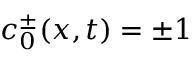Convert formula to latex. <formula><loc_0><loc_0><loc_500><loc_500>c _ { 0 } ^ { \pm } ( x , t ) = \pm 1</formula> 